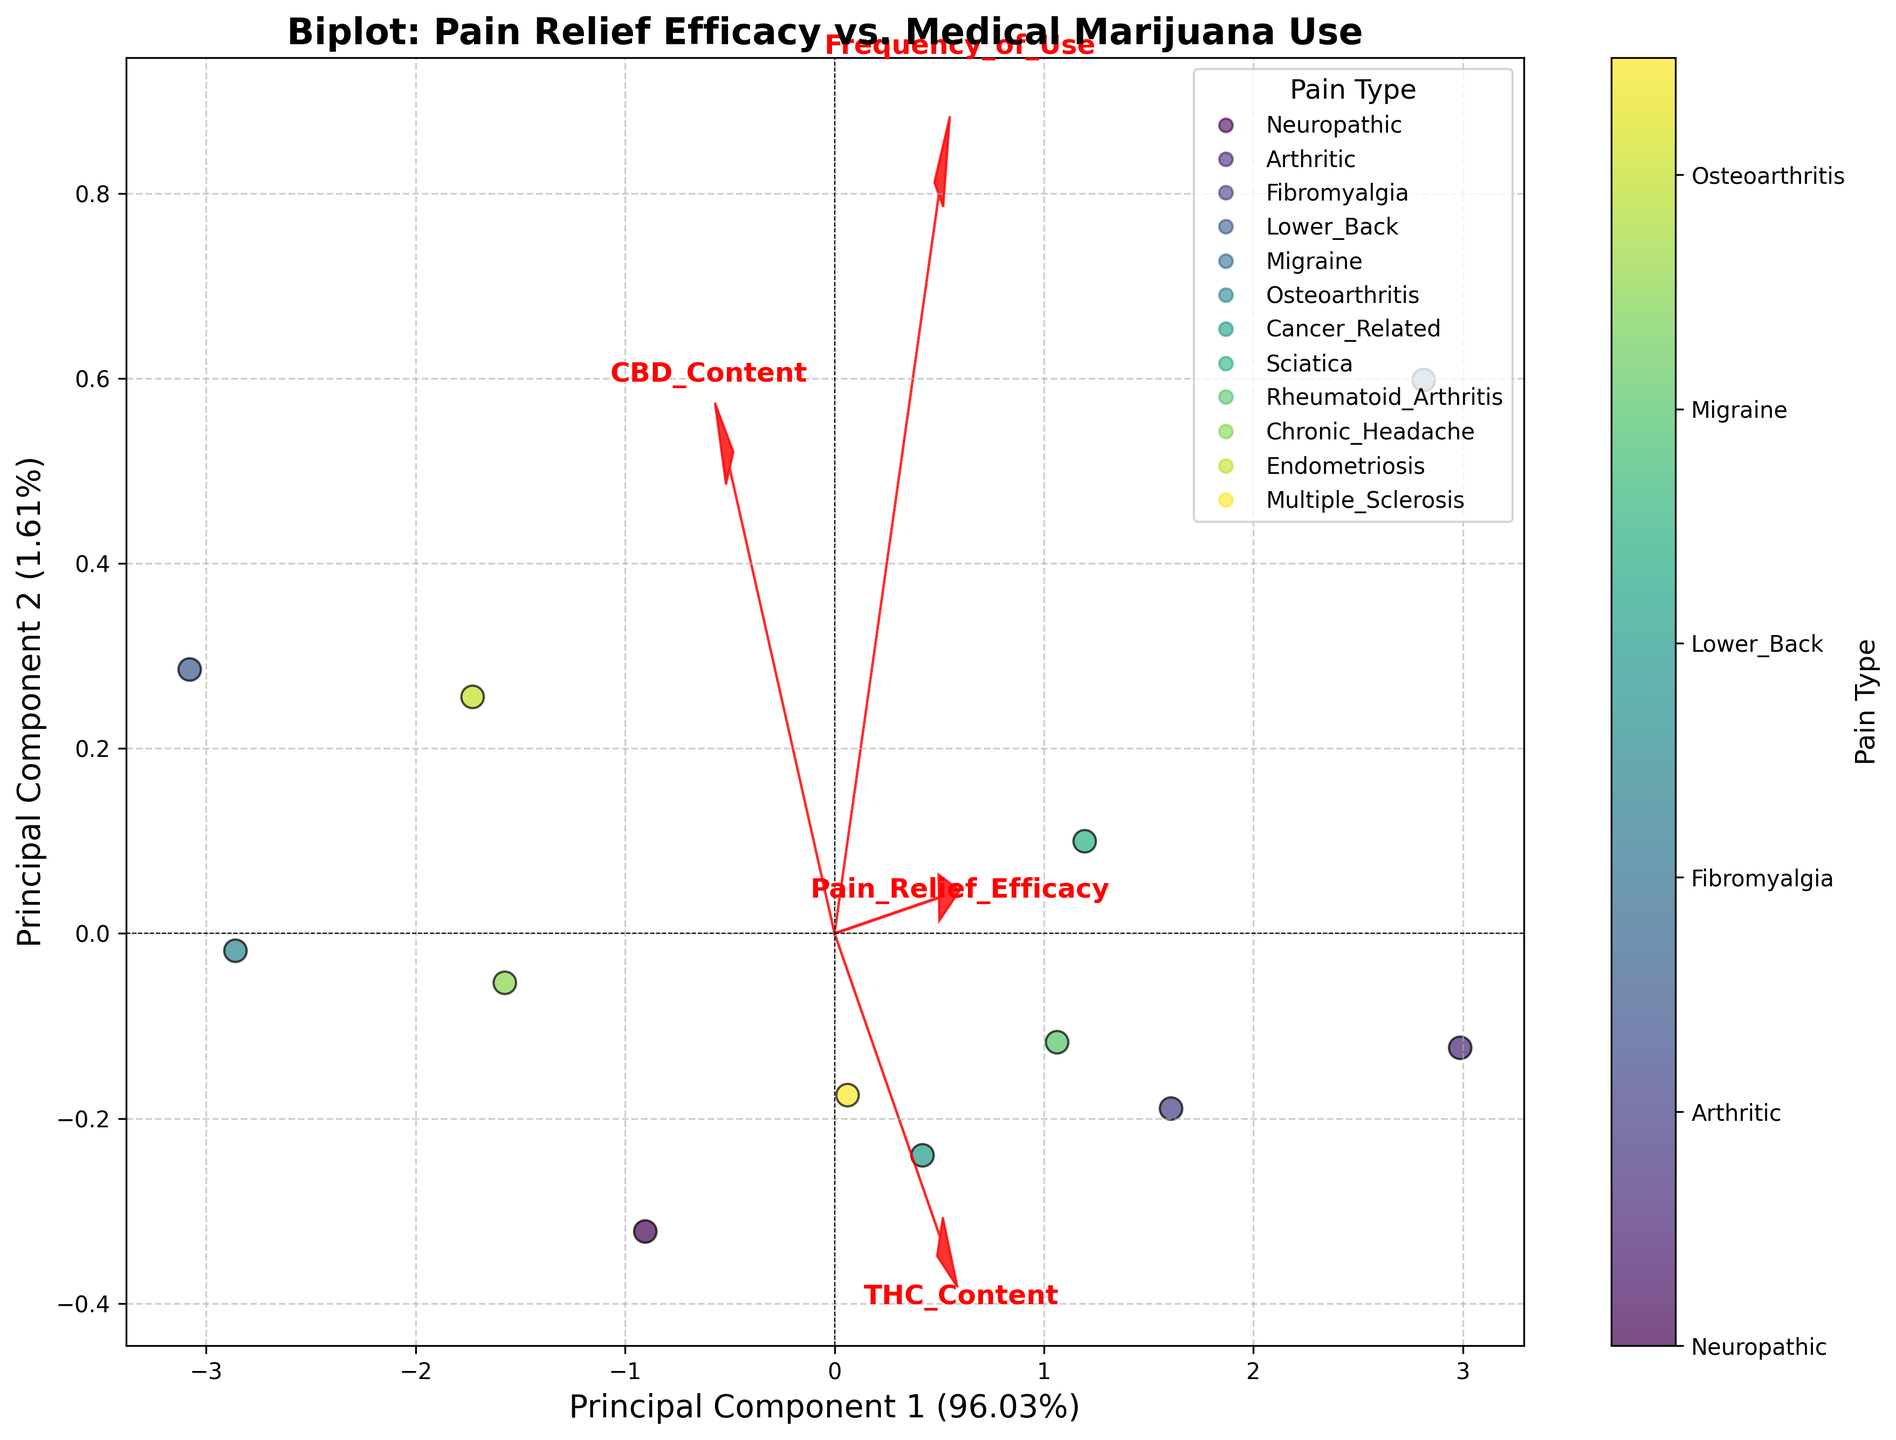How many principal components are being displayed in the biplot? The biplot is generated using PCA with 'n_components=2', so it shows the first two principal components.
Answer: 2 Which axis represents Principal Component 1? The x-axis is labeled as 'Principal Component 1', indicating that it represents the first principal component.
Answer: x-axis What feature is most strongly associated with Principal Component 1? The feature with the longest vector in the direction of Principal Component 1 on the biplot is the most strongly associated.
Answer: To determine this, we need to look at the longest vector aligned with the x-axis How are pain types differentiated in the plot? Pain types are differentiated by color, as indicated by the color legend on the right side of the plot.
Answer: By color What is the title of the biplot? The title is written at the top of the plot.
Answer: "Biplot: Pain Relief Efficacy vs. Medical Marijuana Use" Which pain type has the highest frequency of medical marijuana use? To find this, locate the data point furthest along the vector for "Frequency_of_Use". Check its corresponding pain type using the color coding.
Answer: This requires checking the farthest scatter point along the frequency of use vector Which two features are indicated by red arrows in the biplot? The arrows are labeled with the features they represent.
Answer: There are four arrows, each labeled with "Pain_Relief_Efficacy," "Frequency_of_Use," "THC_Content," and "CBD_Content," respectively What percentage of the variance is explained by Principal Component 2? This information is given on the y-axis label, after "Principal Component 2".
Answer: Principal Component 2 explains 29.16% of the variance How do Pain Relief Efficacy and Frequency of Use relate to each other according to the biplot? By examining the angle and length of the vectors for 'Pain_Relief_Efficacy' and 'Frequency_of_Use', we can determine their relationship. If the vectors are in a similar direction, they have a strong positive correlation.
Answer: Must look at the directions of both vectors which can point out the correlation Which feature seems to have the least contribution to Principal Component 1? Look for the shortest arrow along the x-axis direction as this indicates the least contribution to Principal Component 1.
Answer: We need to see which feature has the shortest vector in the x direction Is there evidence of any pain type clustering in the biplot? Look for groups of data points with the same color that are close to each other in the plot.
Answer: We need to visually assess the plot for clusters 